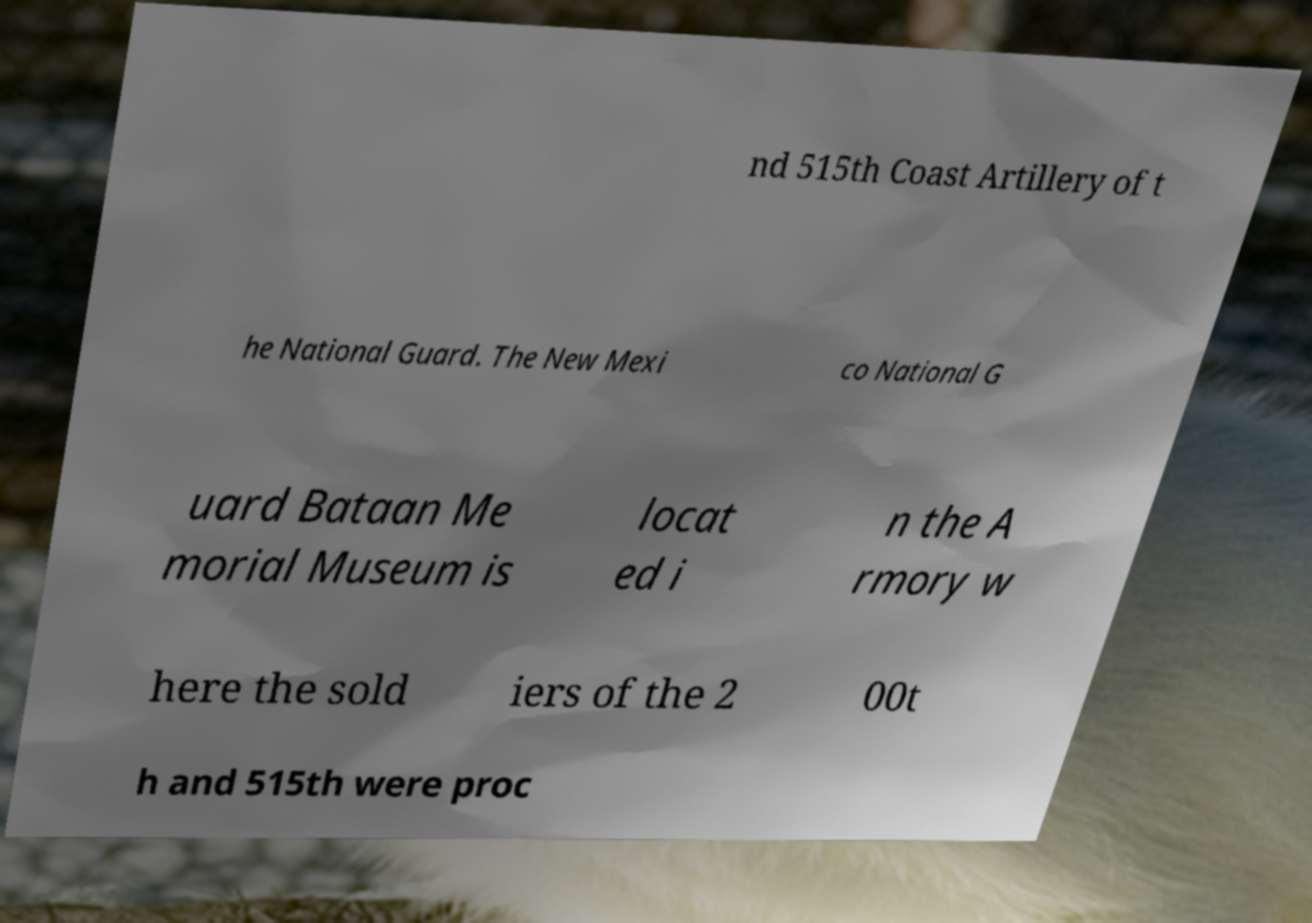There's text embedded in this image that I need extracted. Can you transcribe it verbatim? nd 515th Coast Artillery of t he National Guard. The New Mexi co National G uard Bataan Me morial Museum is locat ed i n the A rmory w here the sold iers of the 2 00t h and 515th were proc 